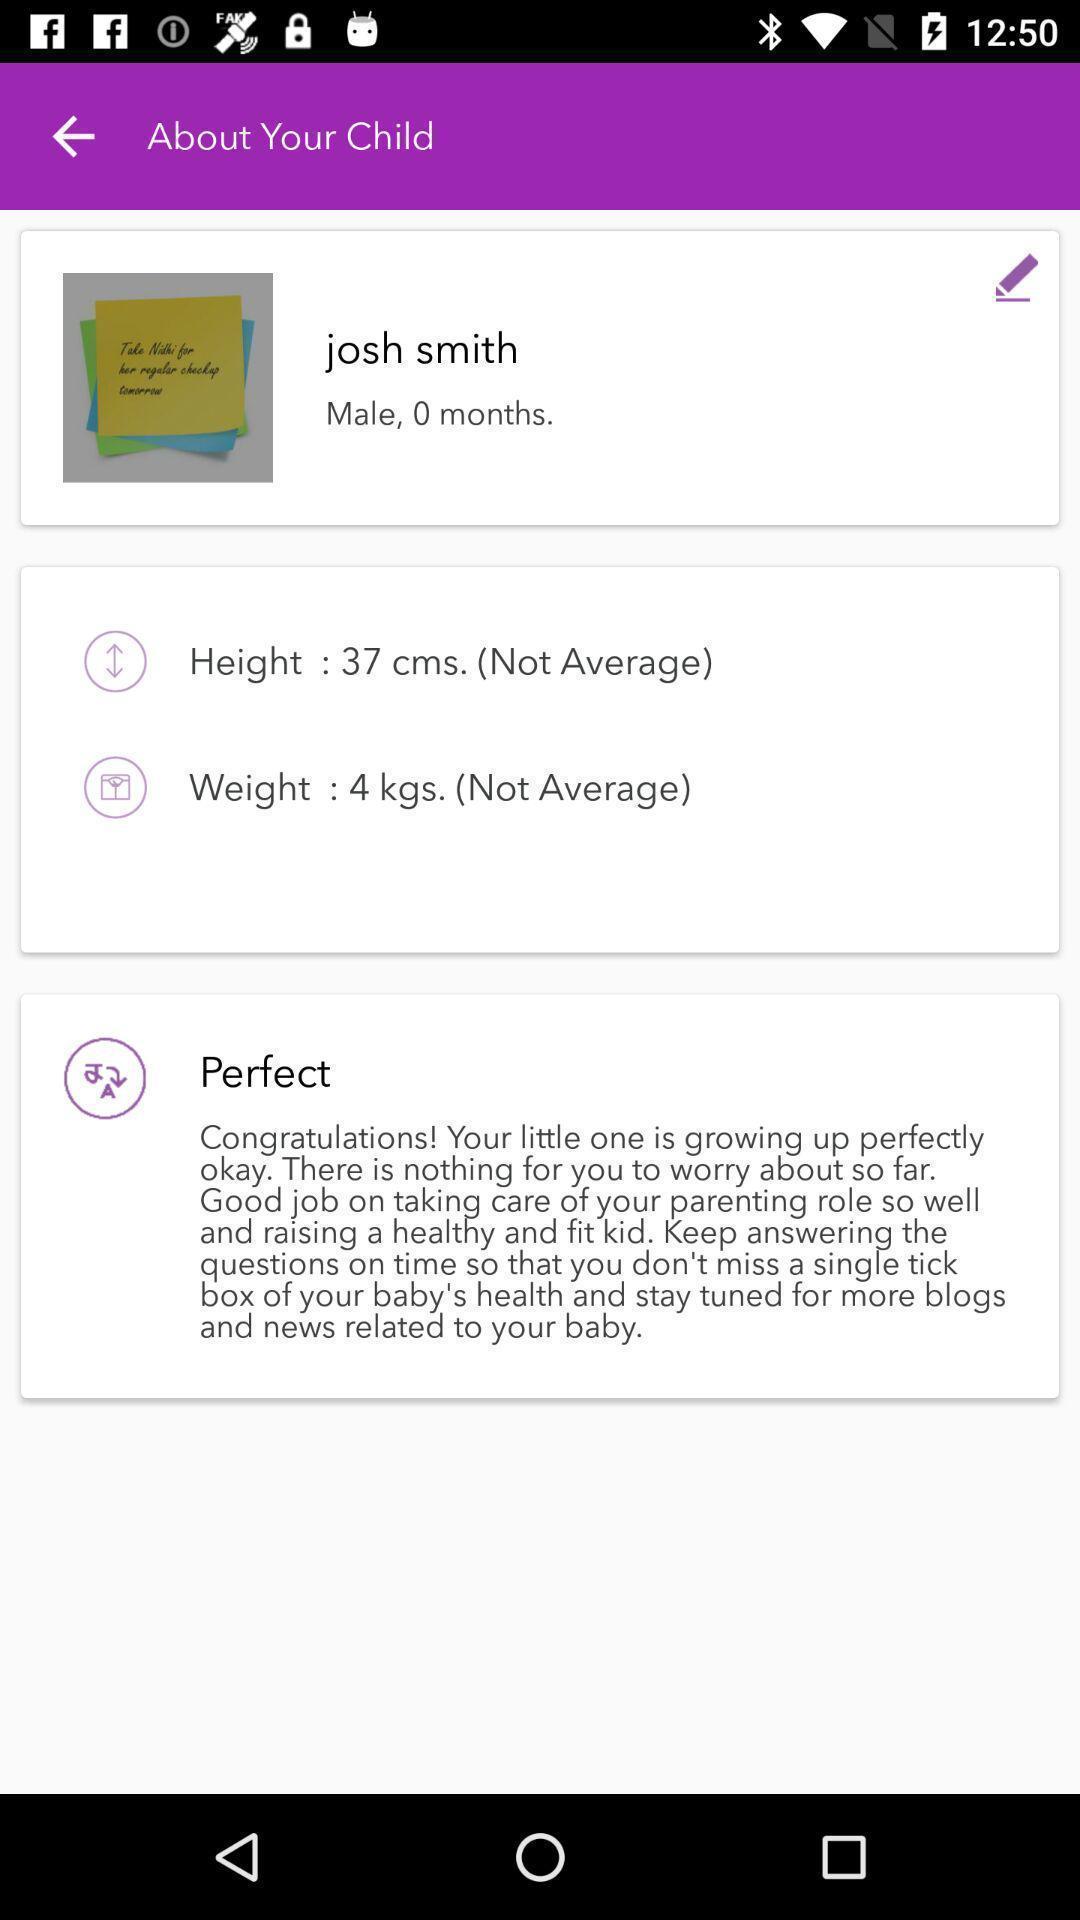What is the overall content of this screenshot? Profile details displayed. 